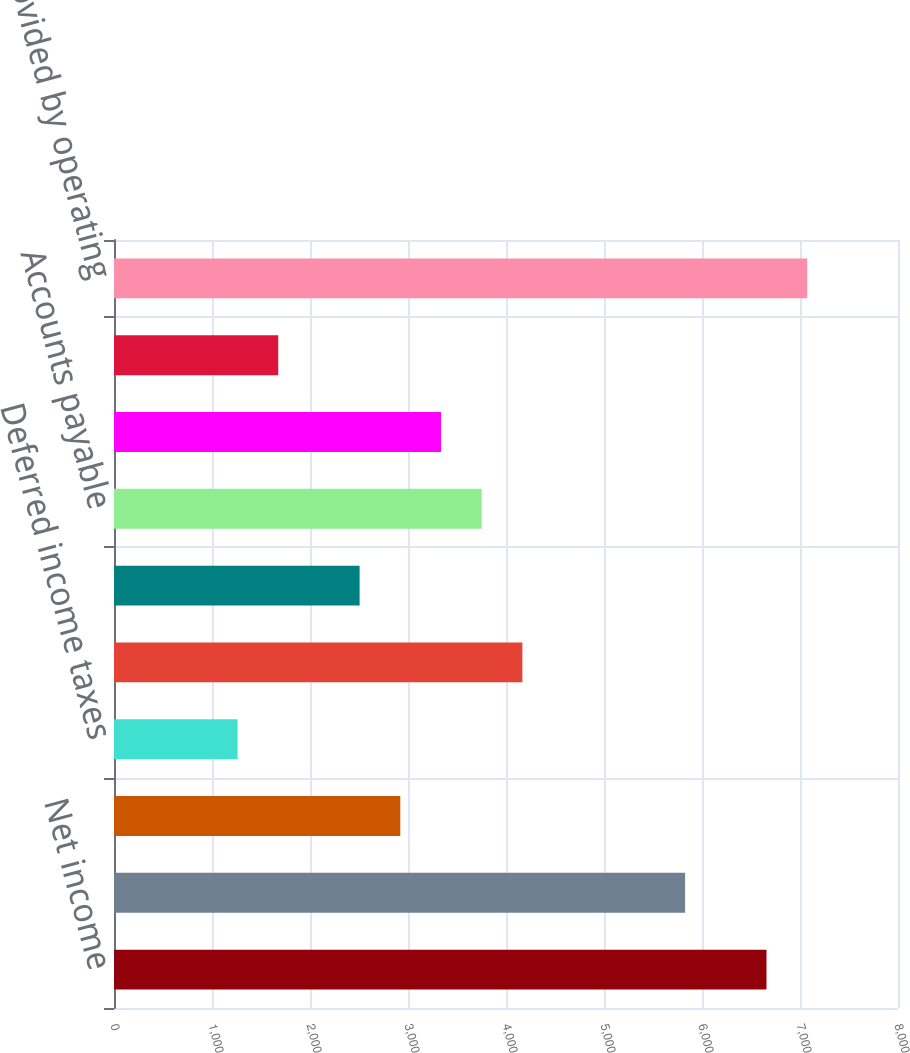<chart> <loc_0><loc_0><loc_500><loc_500><bar_chart><fcel>Net income<fcel>Depreciation and amortization<fcel>Stock-based compensation<fcel>Deferred income taxes<fcel>Accounts receivable net<fcel>Inventories<fcel>Accounts payable<fcel>Accrued expenses<fcel>Other assets and liabilities<fcel>Net cash provided by operating<nl><fcel>6658.2<fcel>5827.8<fcel>2921.4<fcel>1260.6<fcel>4167<fcel>2506.2<fcel>3751.8<fcel>3336.6<fcel>1675.8<fcel>7073.4<nl></chart> 